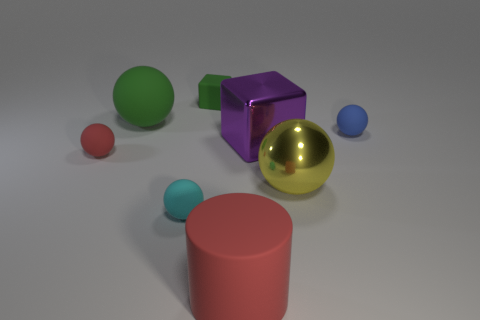There is a red rubber thing that is left of the big matte cylinder; what number of yellow shiny things are on the left side of it?
Ensure brevity in your answer.  0. Are there any other things of the same color as the shiny block?
Make the answer very short. No. What number of things are either purple metal objects or matte objects right of the rubber cube?
Offer a terse response. 3. What is the material of the tiny thing that is in front of the large shiny object that is in front of the red object to the left of the red cylinder?
Give a very brief answer. Rubber. The block that is the same material as the big yellow sphere is what size?
Offer a very short reply. Large. There is a metallic object in front of the red object that is behind the metallic sphere; what is its color?
Your answer should be compact. Yellow. How many tiny spheres have the same material as the blue object?
Ensure brevity in your answer.  2. How many metal objects are either small green blocks or blue spheres?
Offer a very short reply. 0. What is the material of the yellow thing that is the same size as the rubber cylinder?
Ensure brevity in your answer.  Metal. Are there any yellow cubes that have the same material as the large red object?
Ensure brevity in your answer.  No. 